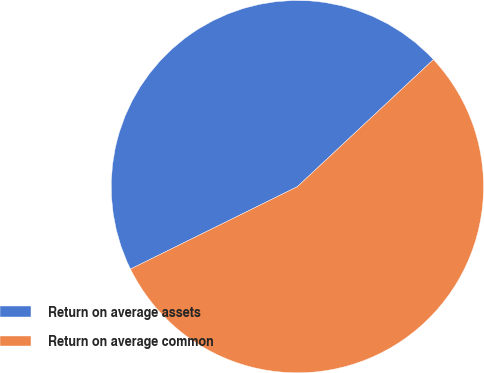Convert chart. <chart><loc_0><loc_0><loc_500><loc_500><pie_chart><fcel>Return on average assets<fcel>Return on average common<nl><fcel>45.34%<fcel>54.66%<nl></chart> 